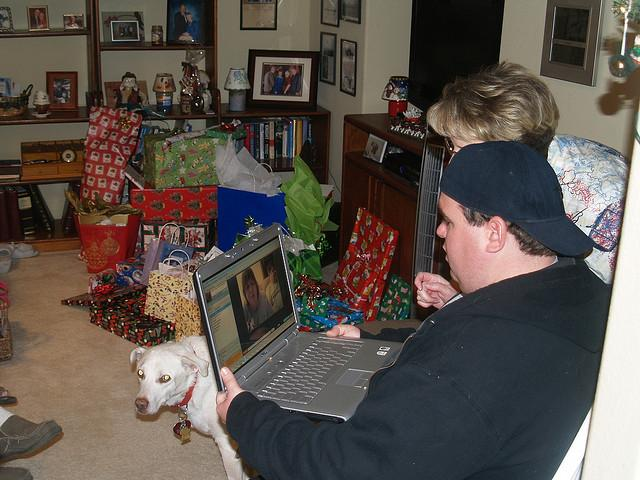What came in all those colored boxes? Please explain your reasoning. presents. The boxes are wrapped in wrapping paper based on the coloring and patterns. boxes wrapped in wrapping paper usually contain presents. 